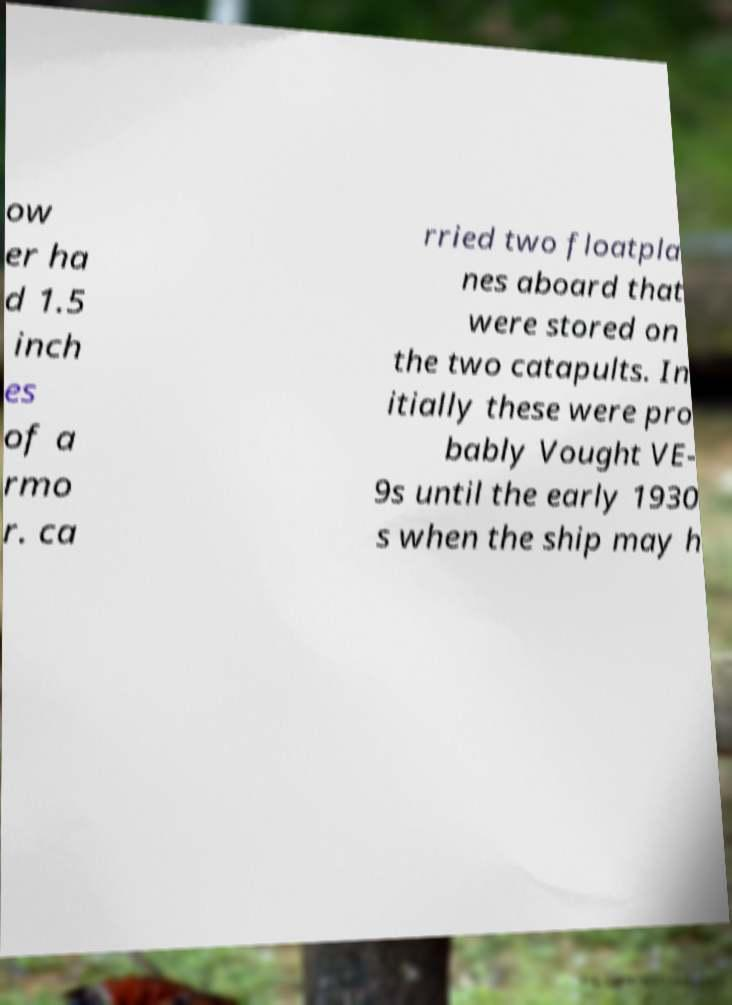I need the written content from this picture converted into text. Can you do that? ow er ha d 1.5 inch es of a rmo r. ca rried two floatpla nes aboard that were stored on the two catapults. In itially these were pro bably Vought VE- 9s until the early 1930 s when the ship may h 